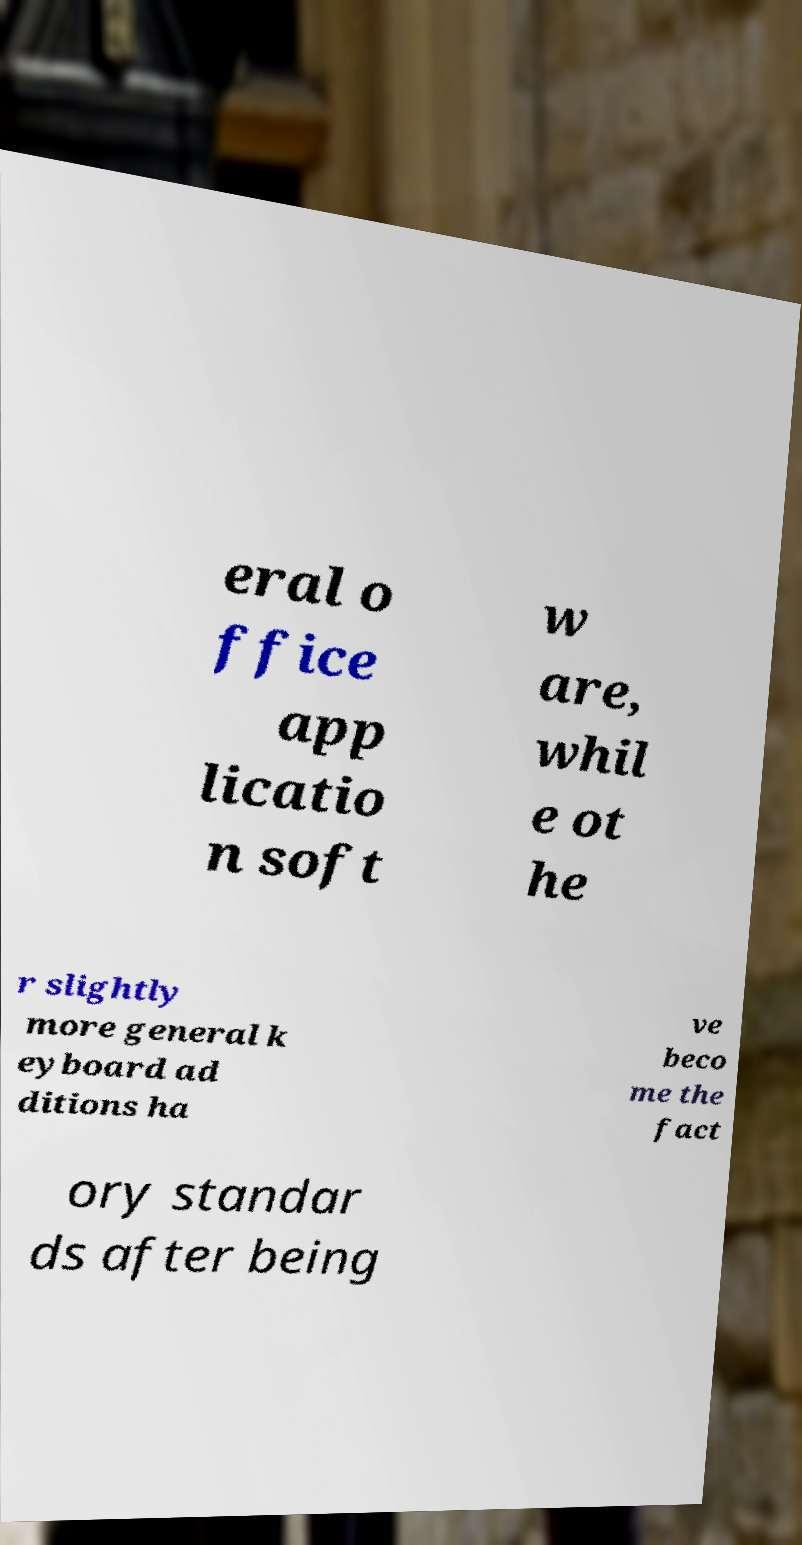Could you extract and type out the text from this image? eral o ffice app licatio n soft w are, whil e ot he r slightly more general k eyboard ad ditions ha ve beco me the fact ory standar ds after being 